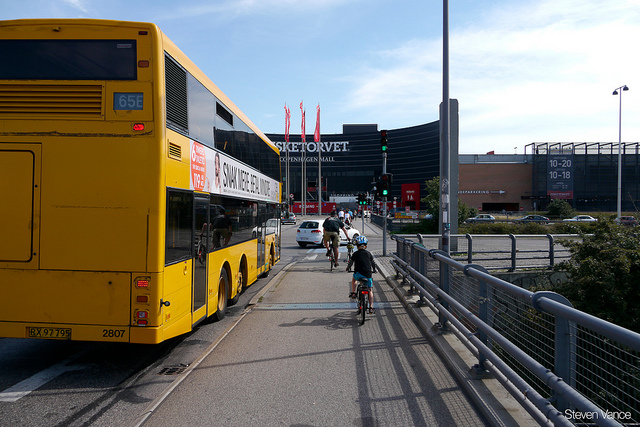Please transcribe the text information in this image. SKETORVET 2807 Vance Steven 10-18 10-20 